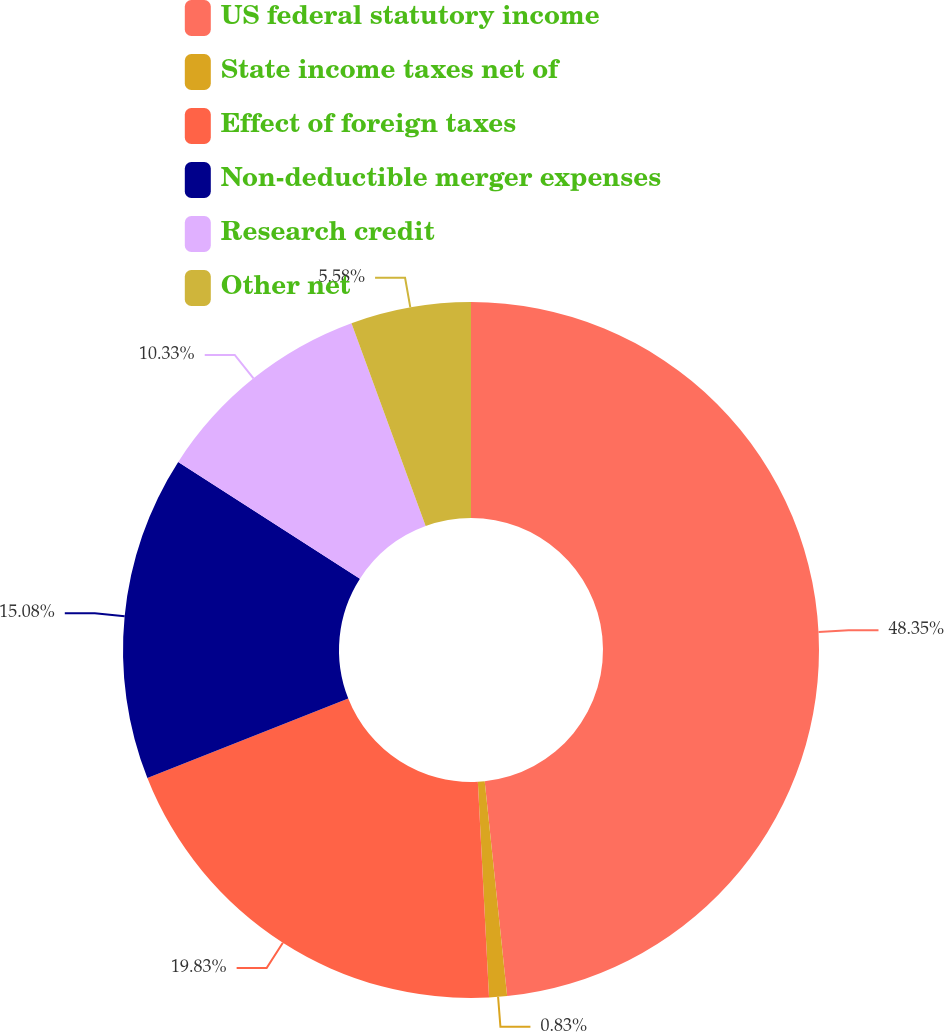Convert chart to OTSL. <chart><loc_0><loc_0><loc_500><loc_500><pie_chart><fcel>US federal statutory income<fcel>State income taxes net of<fcel>Effect of foreign taxes<fcel>Non-deductible merger expenses<fcel>Research credit<fcel>Other net<nl><fcel>48.34%<fcel>0.83%<fcel>19.83%<fcel>15.08%<fcel>10.33%<fcel>5.58%<nl></chart> 